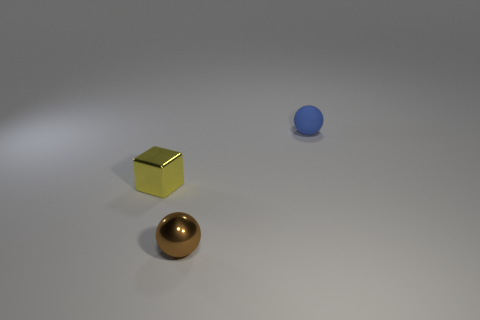What is the size of the yellow metallic object?
Ensure brevity in your answer.  Small. What shape is the brown shiny thing?
Your answer should be compact. Sphere. Is the shape of the tiny brown shiny thing the same as the small metallic thing that is to the left of the small brown thing?
Provide a succinct answer. No. Does the tiny blue object that is behind the shiny sphere have the same shape as the tiny brown shiny thing?
Offer a very short reply. Yes. How many balls are both in front of the blue rubber sphere and right of the brown metallic thing?
Offer a terse response. 0. What number of other things are there of the same size as the blue thing?
Offer a terse response. 2. Are there the same number of tiny rubber objects that are behind the small blue ball and small balls?
Your response must be concise. No. What material is the object that is both right of the block and behind the tiny brown shiny sphere?
Your response must be concise. Rubber. The tiny rubber ball has what color?
Make the answer very short. Blue. How many other objects are the same shape as the yellow metallic thing?
Provide a succinct answer. 0. 